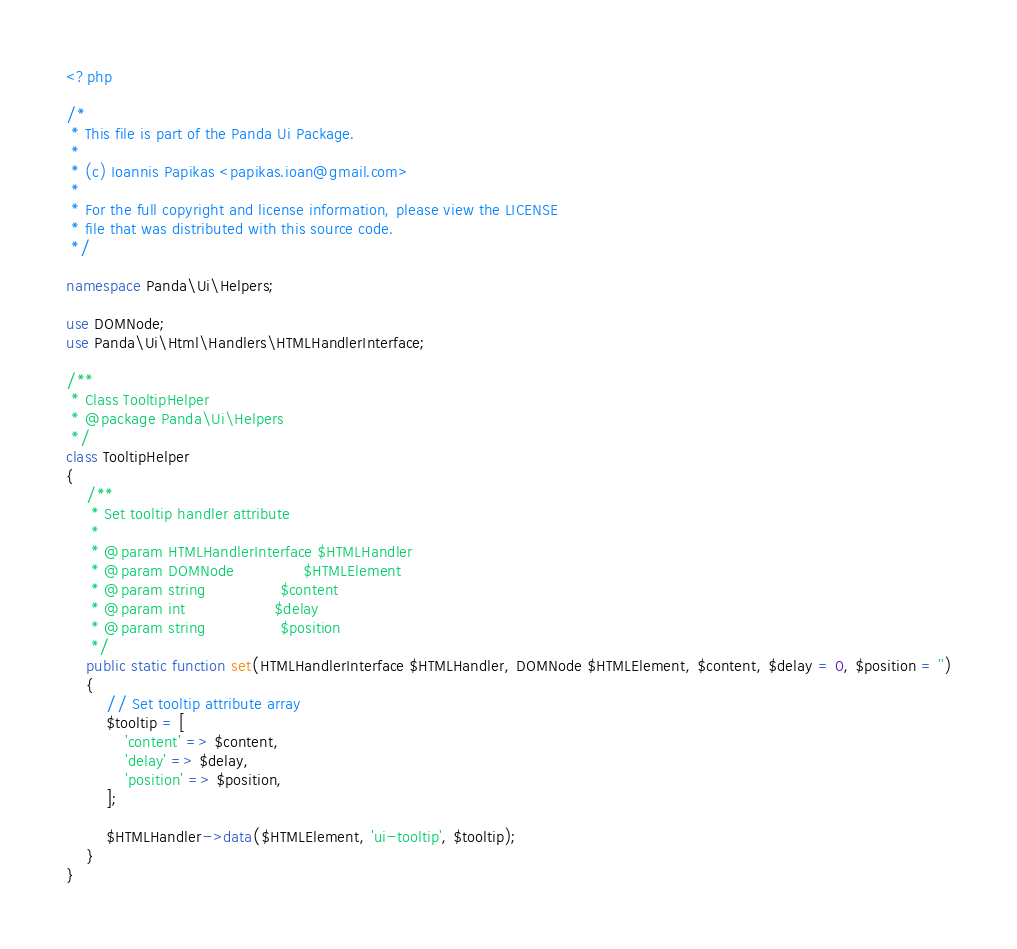Convert code to text. <code><loc_0><loc_0><loc_500><loc_500><_PHP_><?php

/*
 * This file is part of the Panda Ui Package.
 *
 * (c) Ioannis Papikas <papikas.ioan@gmail.com>
 *
 * For the full copyright and license information, please view the LICENSE
 * file that was distributed with this source code.
 */

namespace Panda\Ui\Helpers;

use DOMNode;
use Panda\Ui\Html\Handlers\HTMLHandlerInterface;

/**
 * Class TooltipHelper
 * @package Panda\Ui\Helpers
 */
class TooltipHelper
{
    /**
     * Set tooltip handler attribute
     *
     * @param HTMLHandlerInterface $HTMLHandler
     * @param DOMNode              $HTMLElement
     * @param string               $content
     * @param int                  $delay
     * @param string               $position
     */
    public static function set(HTMLHandlerInterface $HTMLHandler, DOMNode $HTMLElement, $content, $delay = 0, $position = '')
    {
        // Set tooltip attribute array
        $tooltip = [
            'content' => $content,
            'delay' => $delay,
            'position' => $position,
        ];

        $HTMLHandler->data($HTMLElement, 'ui-tooltip', $tooltip);
    }
}
</code> 